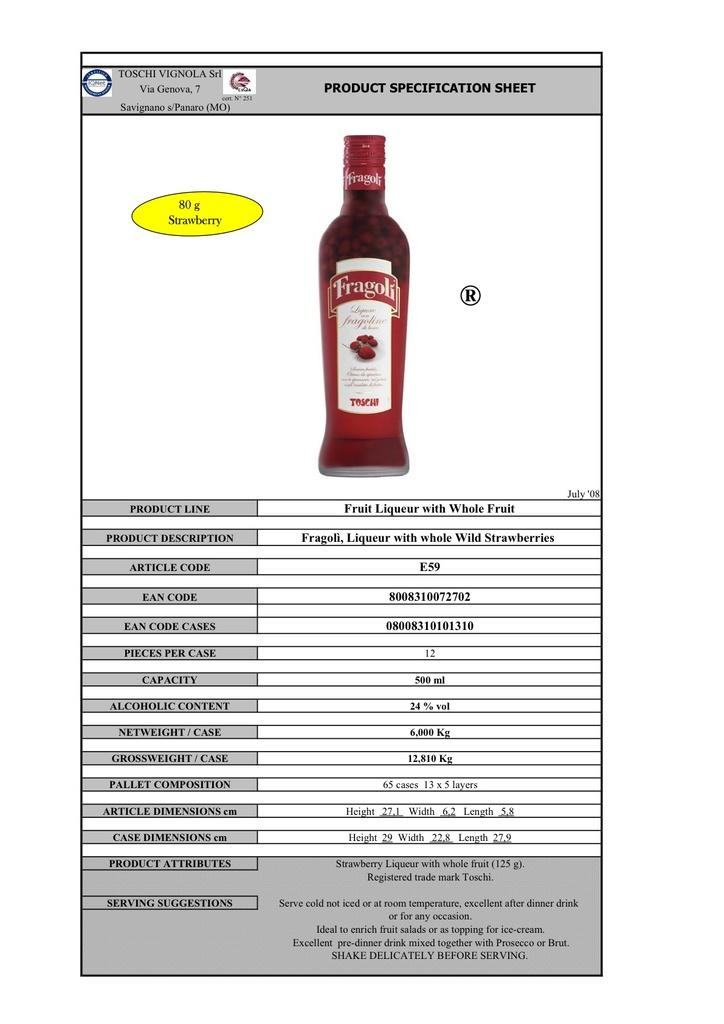<image>
Present a compact description of the photo's key features. A bottle of Fragoli Raspberry Liqueur has product information beneath it 